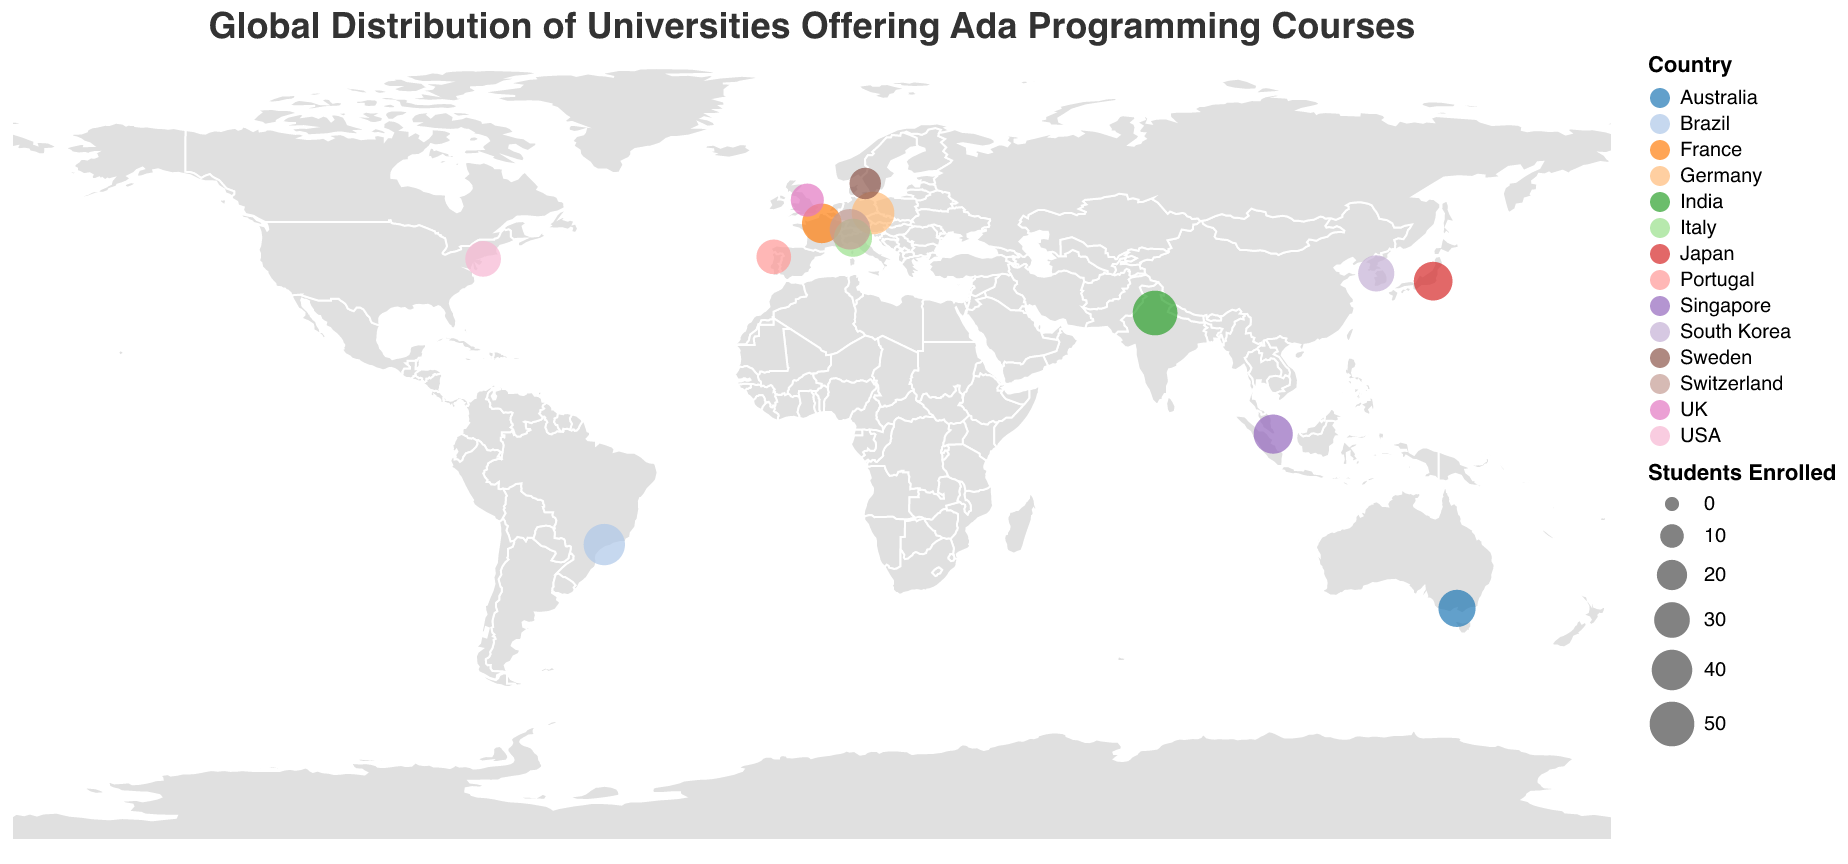What's the title of the plot? The title is displayed at the top of the plot in a larger font size and different color. "Global Distribution of Universities Offering Ada Programming Courses" can be seen clearly.
Answer: Global Distribution of Universities Offering Ada Programming Courses Which country has the university with the highest number of students enrolled in Ada programming courses? Each university is marked with a circle where the size represents the number of students enrolled. The largest circle corresponds to the university with the highest number. From the data, the largest circle is Indian Institute of Technology Delhi with 50 students.
Answer: India What's the total number of students enrolled in Ada programming courses in Europe? There are universities from Germany, France, UK, Italy, Switzerland, Portugal, and Sweden. Adding up the students: 45 (Germany) + 38 (France) + 25 (UK) + 35 (Italy) + 40 (Switzerland) + 28 (Portugal) + 22 (Sweden) = 233.
Answer: 233 Which university has the highest number of students enrolled in Ada programming courses and where is it located? By comparing the size of the circles, we identify the largest one. Indian Institute of Technology Delhi has the highest number (50 students) and is located in India.
Answer: Indian Institute of Technology Delhi, India How many universities from Asia are displayed on the plot? Checking the countries within Asia: Singapore (1), India (1), Japan (1), South Korea (1). There are 4 universities in total.
Answer: 4 What is the average number of students enrolled in Ada programming courses globally? Sum all students and divide by the number of universities. Sum: 45 + 30 + 38 + 25 + 35 + 40 + 28 + 22 + 33 + 37 + 50 + 42 + 36 + 31 = 492. Number of universities: 14. Average = 492 / 14 = 35.14.
Answer: 35.14 Which university in Europe has the least number of students enrolled in Ada programming courses? Among European universities: Germany (45), France (38), UK (25), Italy (35), Switzerland (40), Portugal (28), Sweden (22): University of York in UK has 25 students enrolled.
Answer: University of York, UK What does the color of the circles represent? The legend indicates that the color of the circles represents different countries. Each country is assigned a unique color, showing the geographic distribution of universities.
Answer: Country 